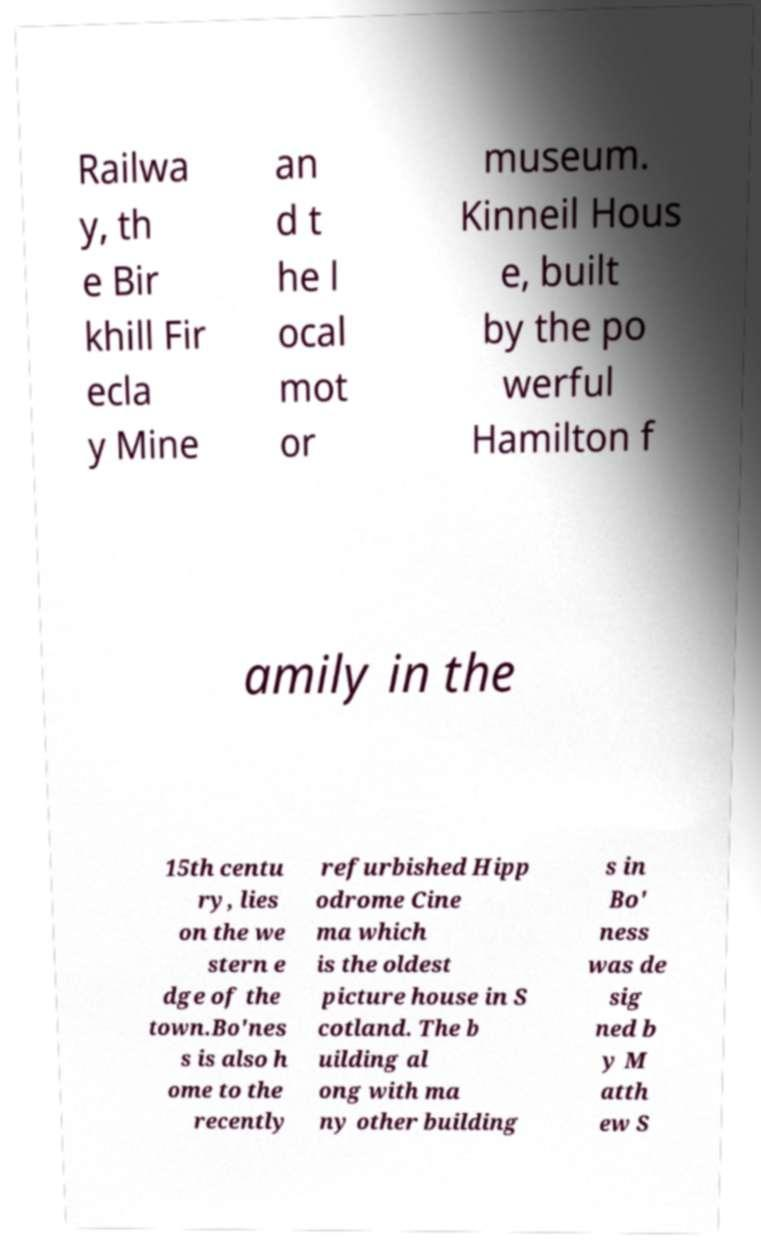There's text embedded in this image that I need extracted. Can you transcribe it verbatim? Railwa y, th e Bir khill Fir ecla y Mine an d t he l ocal mot or museum. Kinneil Hous e, built by the po werful Hamilton f amily in the 15th centu ry, lies on the we stern e dge of the town.Bo'nes s is also h ome to the recently refurbished Hipp odrome Cine ma which is the oldest picture house in S cotland. The b uilding al ong with ma ny other building s in Bo' ness was de sig ned b y M atth ew S 